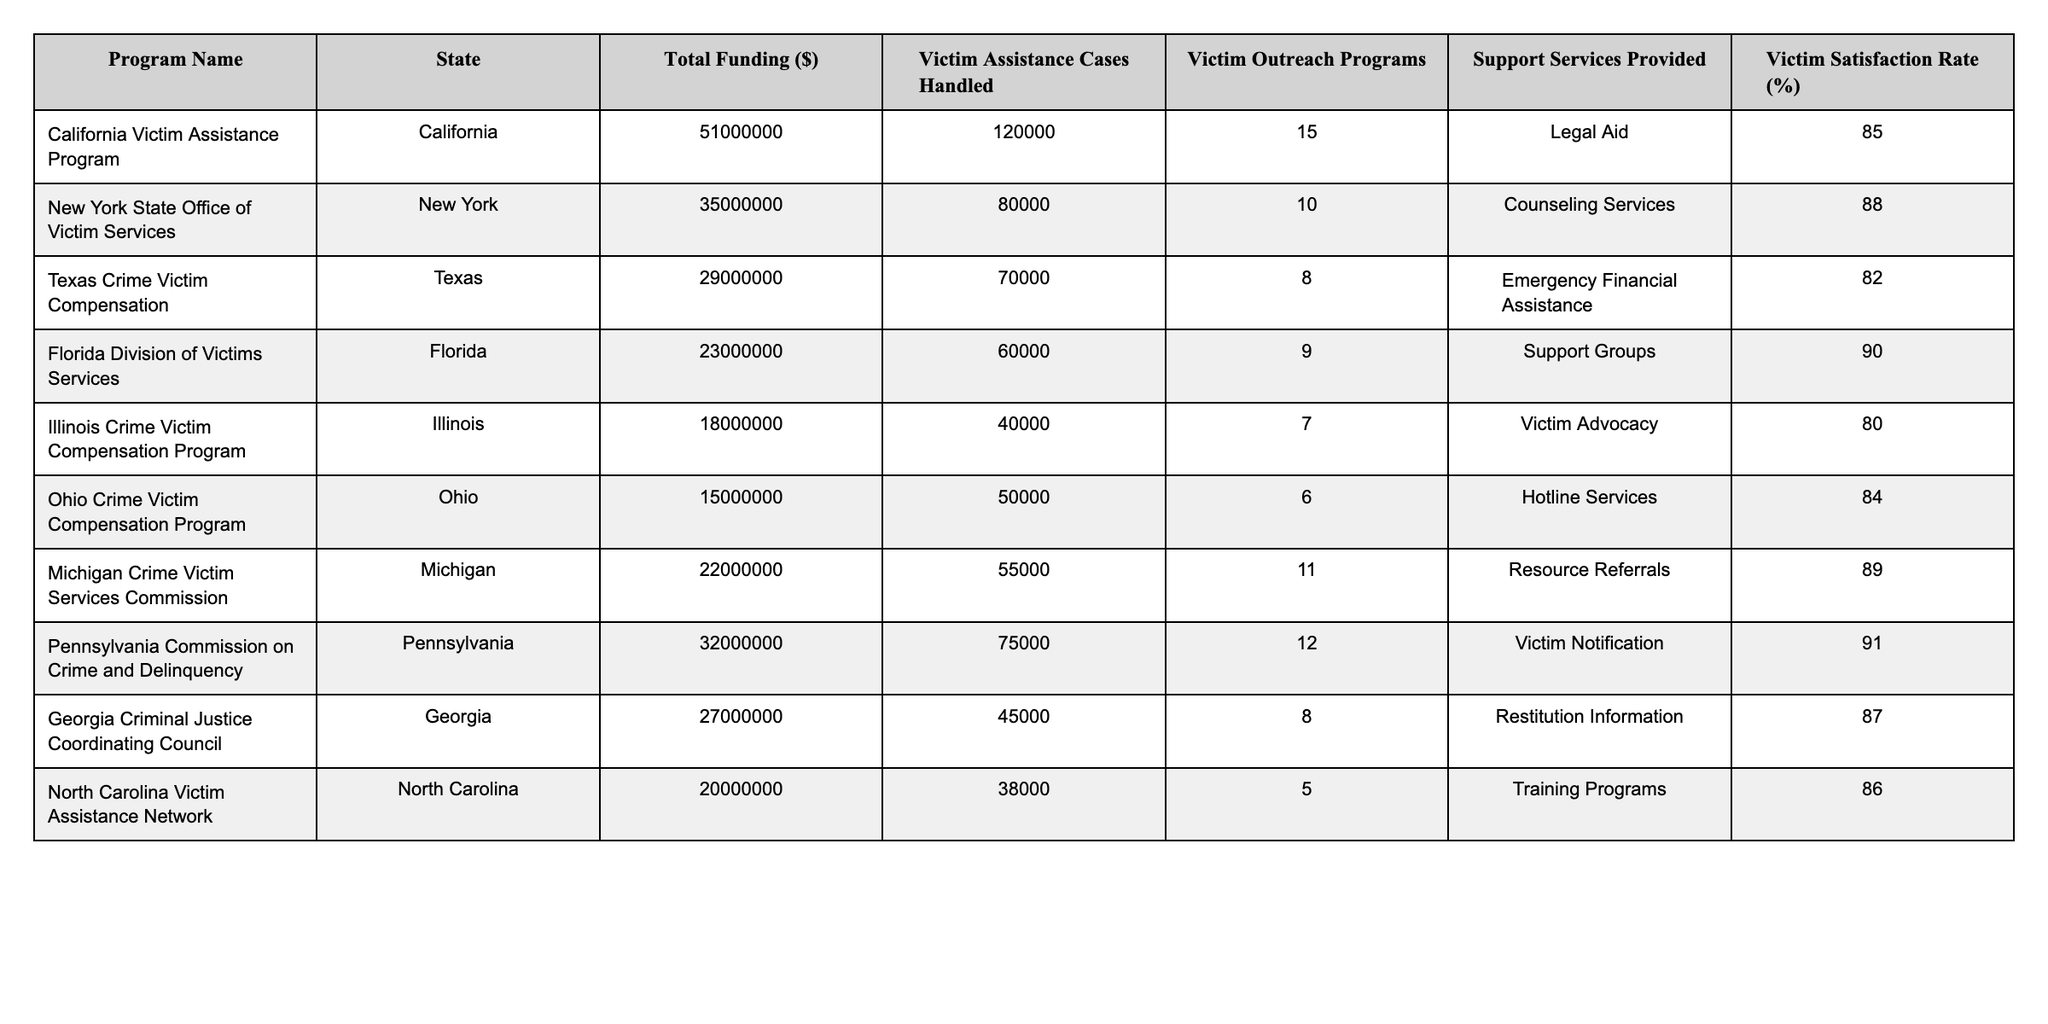What is the total funding for the California Victim Assistance Program? The table states that the Total Funding for the California Victim Assistance Program is $51,000,000.
Answer: $51,000,000 Which program has the highest victim satisfaction rate? Looking at the Victim Satisfaction Rate column, the Florida Division of Victims Services has the highest rate at 90%.
Answer: 90% How many victim assistance cases were handled by the New York State Office of Victim Services? The table shows that the New York State Office of Victim Services handled 80,000 victim assistance cases.
Answer: 80,000 What is the average satisfaction rate of the programs listed? To find the average, we sum the satisfaction rates: (85 + 88 + 82 + 90 + 80 + 84 + 89 + 91 + 87 + 86) = 871. There are 10 programs, so average = 871/10 = 87.1%.
Answer: 87.1% Did any of the programs provide more than 10 outreach programs? By checking the Victim Outreach Programs column, only the California program provided 15 outreach programs, which is greater than 10.
Answer: Yes What is the total funding of all programs combined? We add the funding amounts: 51,000,000 + 35,000,000 + 29,000,000 + 23,000,000 + 18,000,000 + 15,000,000 + 22,000,000 + 32,000,000 + 27,000,000 + 20,000,000 =  280,000,000.
Answer: $280,000,000 What support service is provided by the Michigan Crime Victim Services Commission? The table indicates that the support service provided by the Michigan program is Resource Referrals.
Answer: Resource Referrals Is the victim assistance rate higher in Ohio or in Illinois? Ohio has a victim assistance case handling of 50,000, while Illinois has 40,000; thus, Ohio's assistance cases exceed that of Illinois.
Answer: Ohio is higher Which states have victim outreach programs less than 8? The programs in Illinois (7) and Texas (8) have outreach programs less than 8.
Answer: Illinois and Texas What is the difference in funding between the program with the highest and lowest funding? The highest funding is California with $51,000,000, and the lowest is Illinois with $18,000,000. The difference = 51,000,000 - 18,000,000 = 33,000,000.
Answer: $33,000,000 